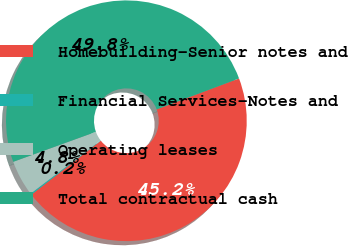Convert chart to OTSL. <chart><loc_0><loc_0><loc_500><loc_500><pie_chart><fcel>Homebuilding-Senior notes and<fcel>Financial Services-Notes and<fcel>Operating leases<fcel>Total contractual cash<nl><fcel>45.19%<fcel>0.18%<fcel>4.81%<fcel>49.82%<nl></chart> 